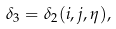<formula> <loc_0><loc_0><loc_500><loc_500>\delta _ { 3 } = \delta _ { 2 } ( i , j , \eta ) ,</formula> 